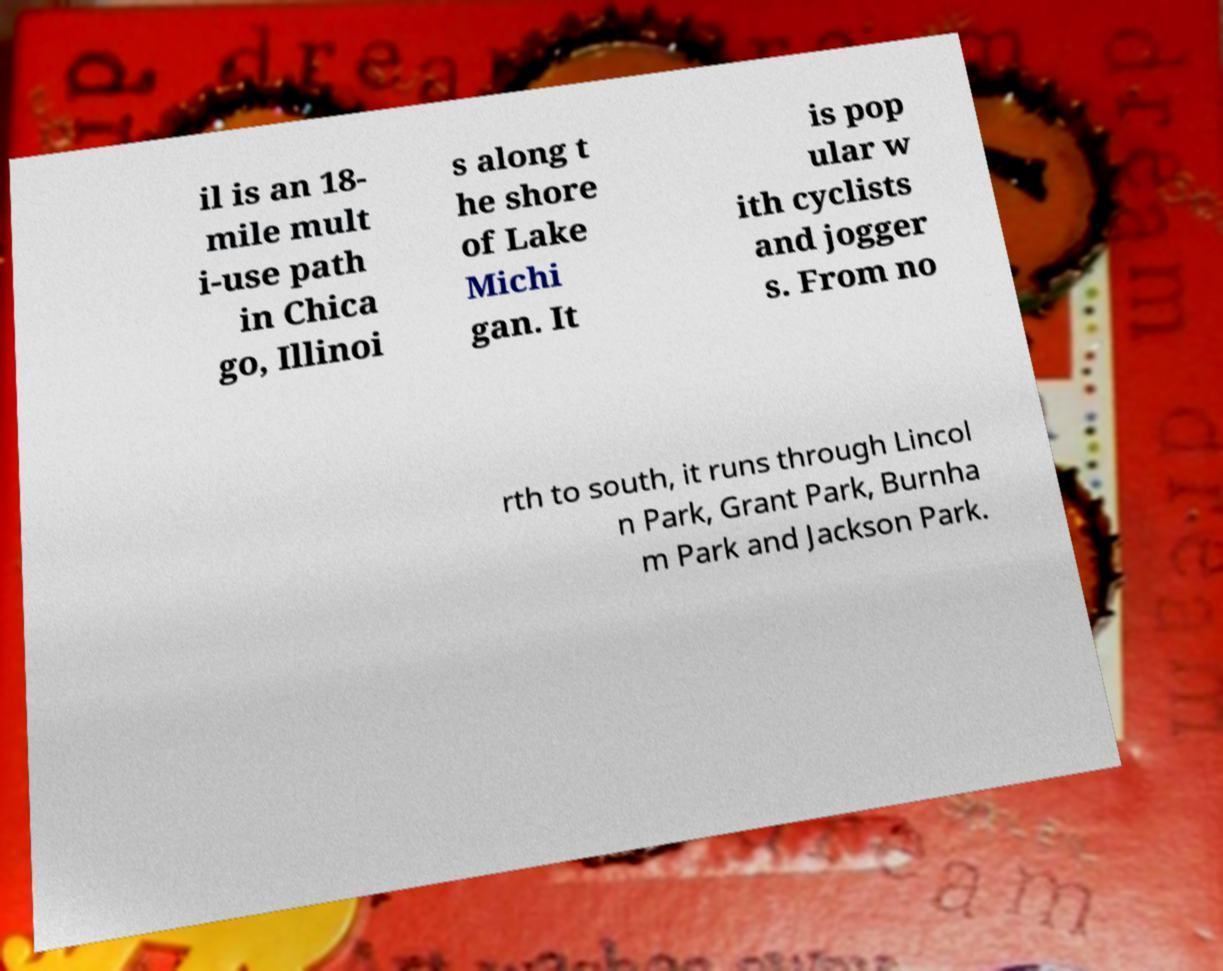There's text embedded in this image that I need extracted. Can you transcribe it verbatim? il is an 18- mile mult i-use path in Chica go, Illinoi s along t he shore of Lake Michi gan. It is pop ular w ith cyclists and jogger s. From no rth to south, it runs through Lincol n Park, Grant Park, Burnha m Park and Jackson Park. 